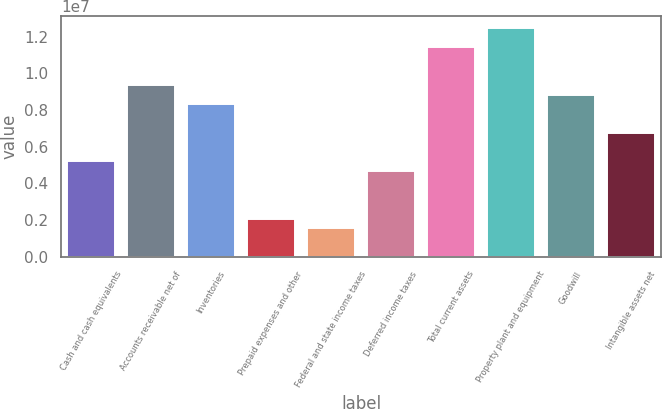Convert chart to OTSL. <chart><loc_0><loc_0><loc_500><loc_500><bar_chart><fcel>Cash and cash equivalents<fcel>Accounts receivable net of<fcel>Inventories<fcel>Prepaid expenses and other<fcel>Federal and state income taxes<fcel>Deferred income taxes<fcel>Total current assets<fcel>Property plant and equipment<fcel>Goodwill<fcel>Intangible assets net<nl><fcel>5.19997e+06<fcel>9.35917e+06<fcel>8.31937e+06<fcel>2.08058e+06<fcel>1.56068e+06<fcel>4.68007e+06<fcel>1.14388e+07<fcel>1.24786e+07<fcel>8.83927e+06<fcel>6.75967e+06<nl></chart> 